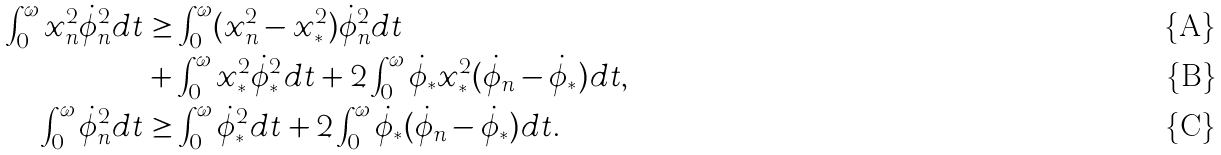Convert formula to latex. <formula><loc_0><loc_0><loc_500><loc_500>\int _ { 0 } ^ { \omega } x _ { n } ^ { 2 } \dot { \phi } _ { n } ^ { 2 } d t & \geq \int _ { 0 } ^ { \omega } ( x _ { n } ^ { 2 } - x _ { * } ^ { 2 } ) \dot { \phi } _ { n } ^ { 2 } d t \\ & + \int _ { 0 } ^ { \omega } x _ { * } ^ { 2 } \dot { \phi } _ { * } ^ { 2 } d t + 2 \int _ { 0 } ^ { \omega } \dot { \phi } _ { * } x _ { * } ^ { 2 } ( \dot { \phi } _ { n } - \dot { \phi } _ { * } ) d t , \\ \int _ { 0 } ^ { \omega } \dot { \phi } _ { n } ^ { 2 } d t & \geq \int _ { 0 } ^ { \omega } \dot { \phi } _ { * } ^ { 2 } d t + 2 \int _ { 0 } ^ { \omega } \dot { \phi } _ { * } ( \dot { \phi } _ { n } - \dot { \phi } _ { * } ) d t .</formula> 